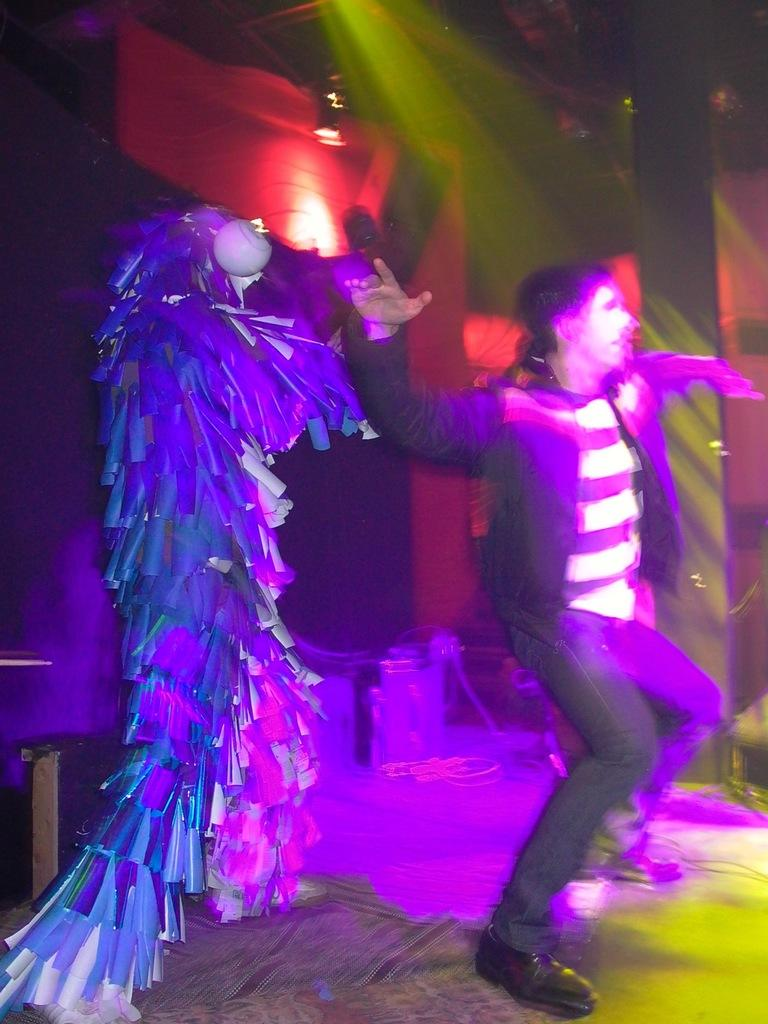What are the people in the image doing? The people in the image are dancing on the stage. Can you describe the person on the left side of the stage? The person on the left side of the stage is wearing a fancy dress. What can be seen at the top of the image? There are lights visible at the top of the image. What type of sleet is falling on the stage during the performance? There is no sleet present in the image; it is an indoor performance with lights visible at the top. 